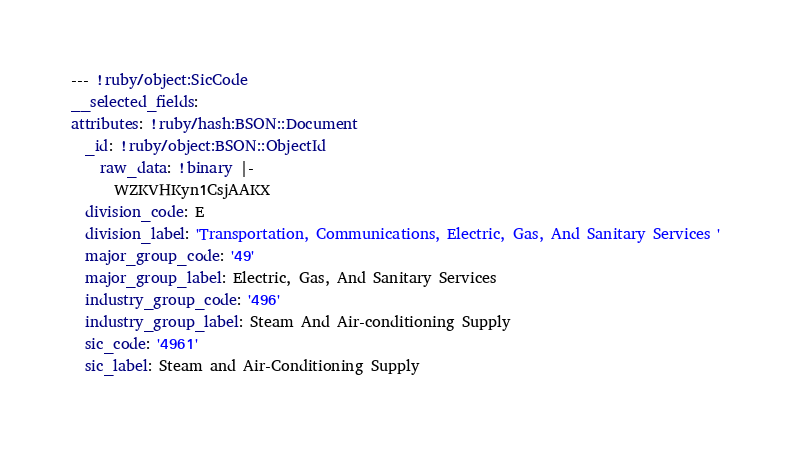<code> <loc_0><loc_0><loc_500><loc_500><_YAML_>--- !ruby/object:SicCode
__selected_fields: 
attributes: !ruby/hash:BSON::Document
  _id: !ruby/object:BSON::ObjectId
    raw_data: !binary |-
      WZKVHKyn1CsjAAKX
  division_code: E
  division_label: 'Transportation, Communications, Electric, Gas, And Sanitary Services '
  major_group_code: '49'
  major_group_label: Electric, Gas, And Sanitary Services
  industry_group_code: '496'
  industry_group_label: Steam And Air-conditioning Supply
  sic_code: '4961'
  sic_label: Steam and Air-Conditioning Supply
</code> 